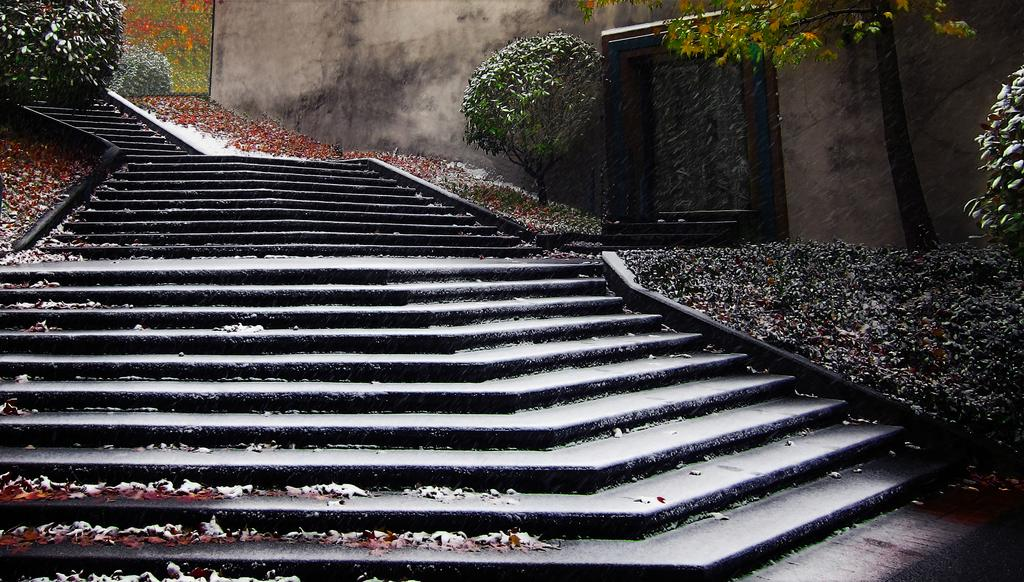What can be seen in the image that people use to move between different levels? There are stairs in the image that people use to move between different levels. What type of vegetation is present near the stairs? There are plants around the stairs. What is on the right side of the image? There is a wall on the right side of the image. What is the grade of the zinc used to construct the stairs in the image? There is no mention of zinc or any construction material in the image, so it is not possible to determine the grade of the zinc used. 